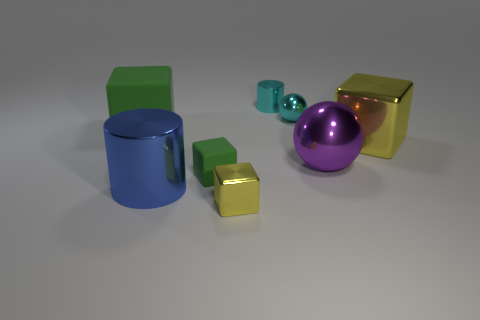Subtract 1 cubes. How many cubes are left? 3 Add 2 green rubber blocks. How many objects exist? 10 Subtract all balls. How many objects are left? 6 Add 4 tiny yellow metallic cubes. How many tiny yellow metallic cubes are left? 5 Add 1 big purple cubes. How many big purple cubes exist? 1 Subtract 0 blue balls. How many objects are left? 8 Subtract all large purple objects. Subtract all small matte things. How many objects are left? 6 